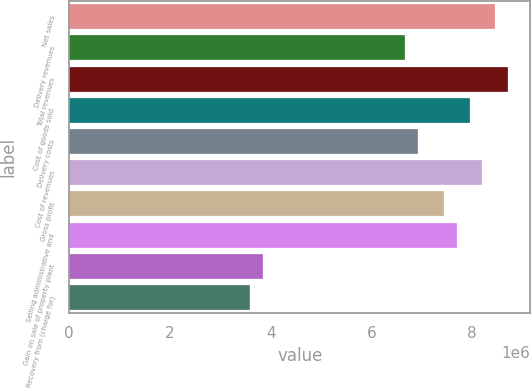<chart> <loc_0><loc_0><loc_500><loc_500><bar_chart><fcel>Net sales<fcel>Delivery revenues<fcel>Total revenues<fcel>Cost of goods sold<fcel>Delivery costs<fcel>Cost of revenues<fcel>Gross profit<fcel>Selling administrative and<fcel>Gain on sale of property plant<fcel>Recovery from (charge for)<nl><fcel>8.46302e+06<fcel>6.66783e+06<fcel>8.71947e+06<fcel>7.95011e+06<fcel>6.92429e+06<fcel>8.20656e+06<fcel>7.4372e+06<fcel>7.69365e+06<fcel>3.84683e+06<fcel>3.59037e+06<nl></chart> 